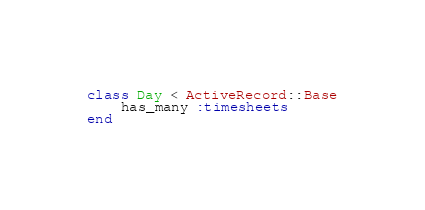<code> <loc_0><loc_0><loc_500><loc_500><_Ruby_>class Day < ActiveRecord::Base
	has_many :timesheets
end
</code> 